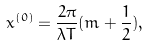<formula> <loc_0><loc_0><loc_500><loc_500>x ^ { ( 0 ) } = \frac { 2 \pi } { \lambda T } ( m + \frac { 1 } { 2 } ) ,</formula> 